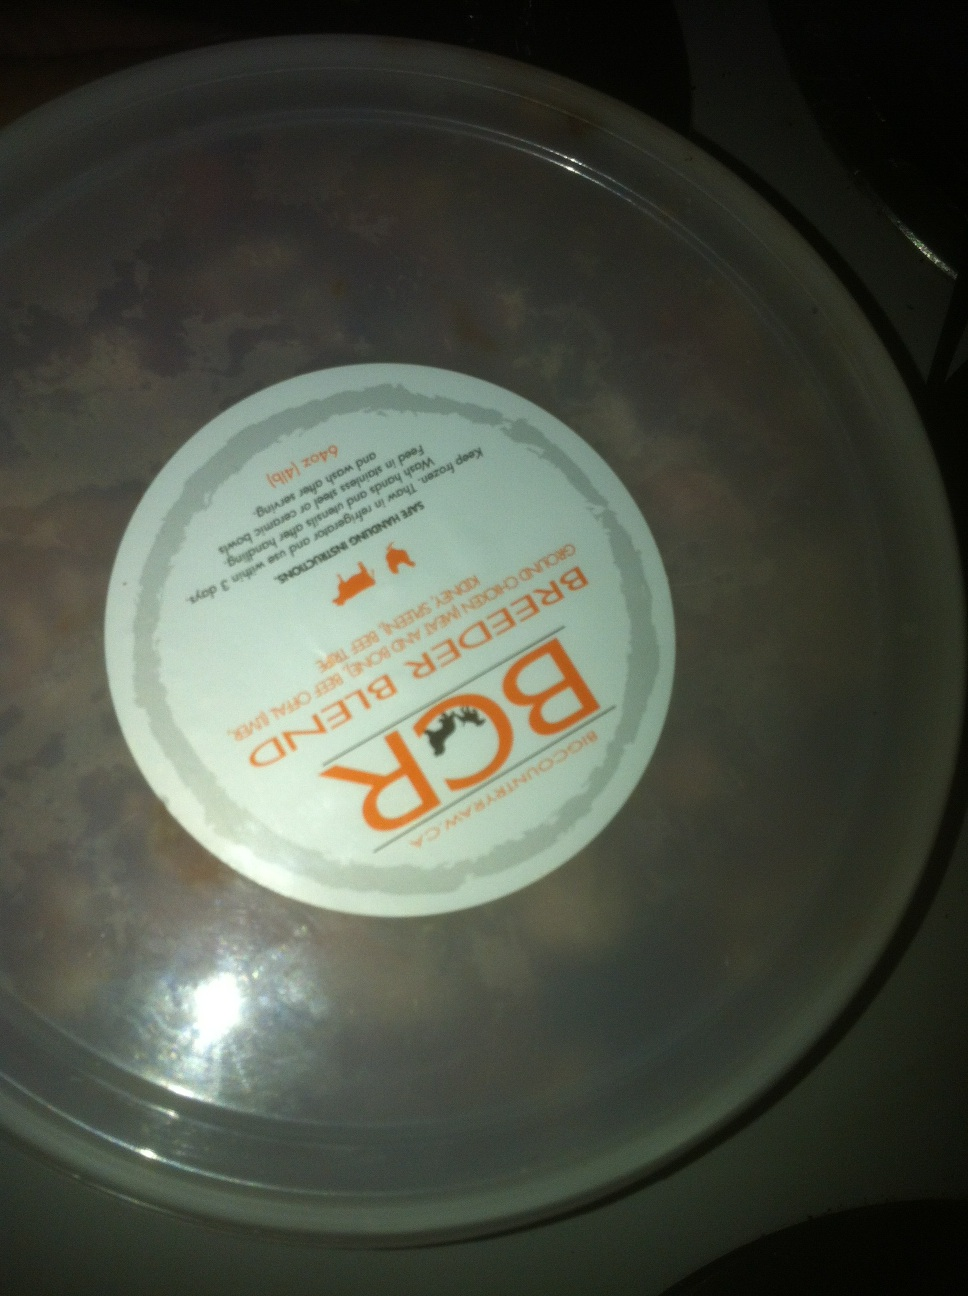Does this say reader's blend or beef dinner? Upon examining the image provided, the label appears to say 'Beef Dinner.' This is inferred from the legible part of the text and the common association of such labels with food products. However, due to reflections and partial obscurity of the text, there is some uncertainty. To be completely certain, an additional clear and well-lit picture would be helpful. 